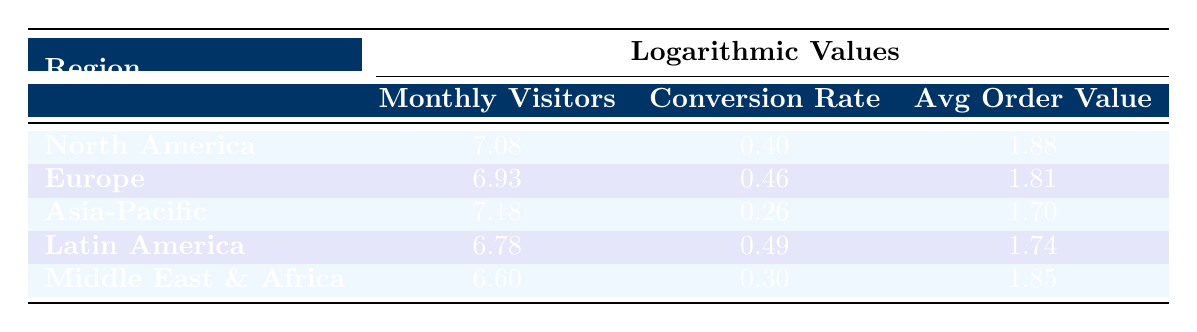What is the monthly visitors log value for North America? The table shows that the monthly visitors for North America is 12,000,000. The logarithmic value associated with this is 7.08.
Answer: 7.08 Which region has the highest average order value? From the table, Asia-Pacific has an average order value of 1.70, which is higher than Europe (1.81), North America (1.88), Latin America (1.74), and Middle East & Africa (1.85). Therefore, North America is the highest.
Answer: North America How do the conversion rates of Latin America and Europe compare? The conversion rate for Latin America is 0.49 and for Europe, it is 0.46. Comparing these values shows that Latin America has a higher conversion rate than Europe.
Answer: Latin America is higher What is the difference in logarithmic monthly visitors between Asia-Pacific and Europe? The logarithmic monthly visitors for Asia-Pacific is 7.18 and for Europe, it is 6.93. The difference can be found by subtracting: 7.18 - 6.93 = 0.25.
Answer: 0.25 Is the conversion rate for the Middle East & Africa above 0.3? The conversion rate for the Middle East & Africa is 0.30, which means it is not above 0.3. Therefore, the answer is no.
Answer: No Which region has a lower average order value, Latin America or Asia-Pacific? The average order value for Latin America is 1.74, whereas for Asia-Pacific it is 1.70. Thus, we see that Asia-Pacific has a lower average order value than Latin America.
Answer: Asia-Pacific What is the average conversion rate across all regions? To find the average conversion rate, we sum the conversion rates: 0.40 + 0.46 + 0.26 + 0.49 + 0.30 = 1.91. We then divide by the number of regions, which is 5: 1.91 / 5 = 0.382.
Answer: 0.382 Based on the data, does North America have the most monthly visitors? The monthly visitors for North America are 12,000,000, which is higher than any other region's monthly visitors listed in the table.
Answer: Yes 